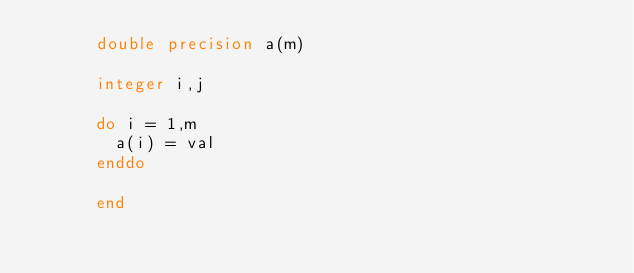Convert code to text. <code><loc_0><loc_0><loc_500><loc_500><_FORTRAN_>      double precision a(m)

      integer i,j

      do i = 1,m
        a(i) = val
      enddo

      end</code> 